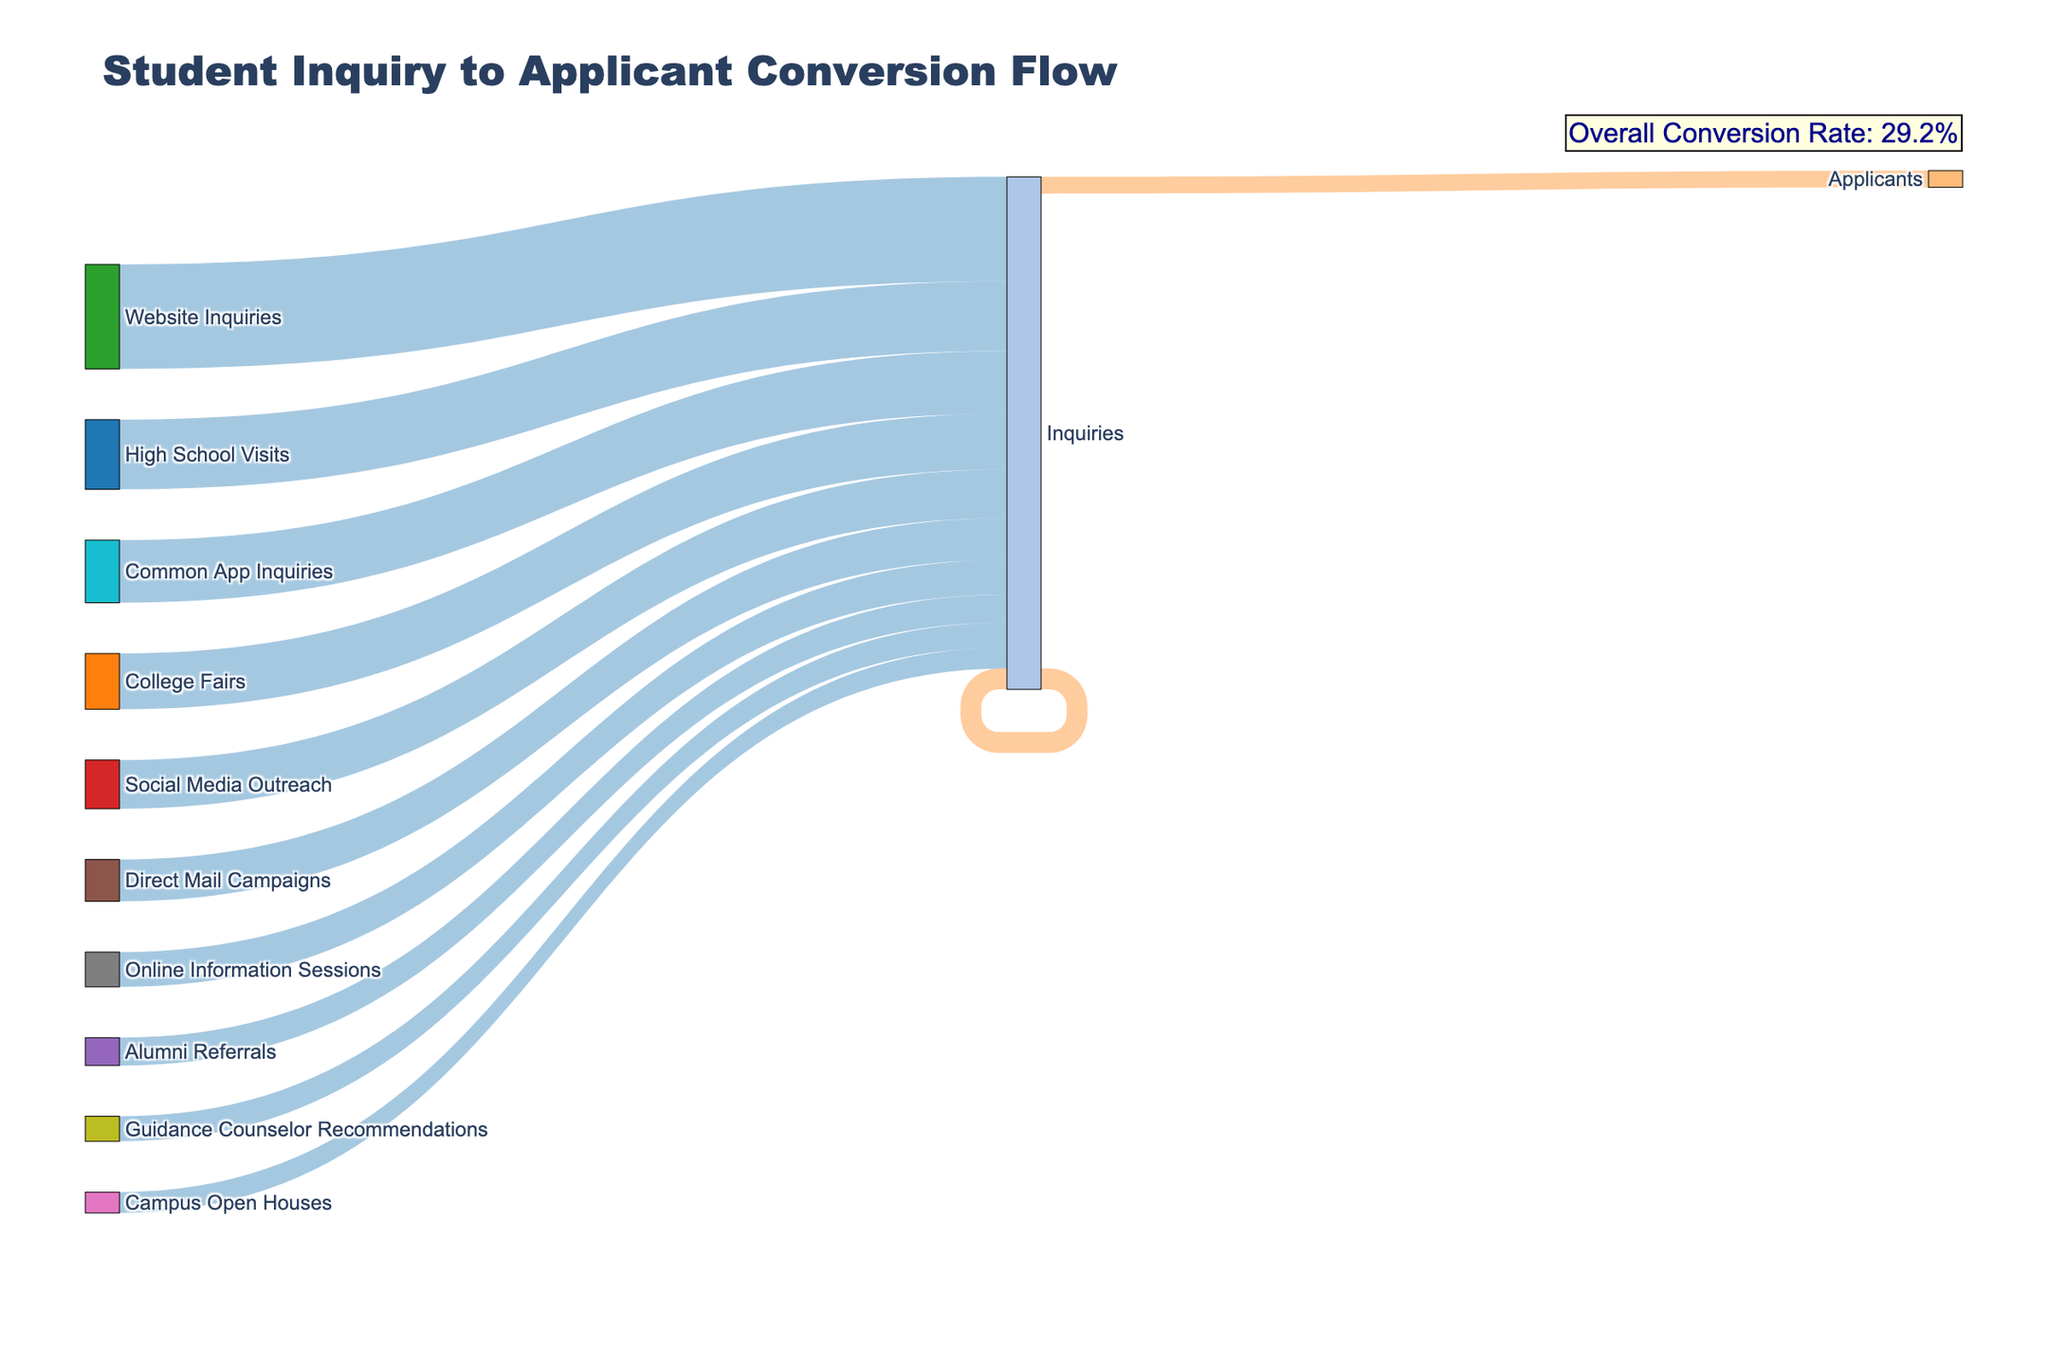What's the title of the figure? The title is usually displayed prominently at the top of the figure. From our code, the title is set as "Student Inquiry to Applicant Conversion Flow" on line 36.
Answer: Student Inquiry to Applicant Conversion Flow Which inquiry source has the highest number of applicants? From the figure, you can trace each inquiry source to the number of applicants connected to it. "Website Inquiries" has the longest flow leading to the applicant node, indicating it as the source with the highest applicants.
Answer: Website Inquiries How many total inquiries are represented in the figure? The total inquiries can be calculated by summing the inquiries from all sources. From our data: 5000 + 4000 + 7500 + 3500 + 2000 + 3000 + 1500 + 2500 + 1800 + 4500 = 35300.
Answer: 35300 What is the overall conversion rate from inquiries to applicants? This was explicitly annotated in the figure as 100 times the ratio of total applicants to total inquiries. We calculated this in the code as follows: Total inquiries = 35300, total applicants = 10600. Conversion rate = (10600 / 35300) * 100% ≈ 30%.
Answer: 30% Which source has the lowest conversion rate to applicants? The conversion rate for each source can be derived by dividing the number of applicants from each source by the number of inquiries from that source and comparing them. From our data: Direct Mail Campaigns (600/3000 = 0.2 or 20%) is the lowest.
Answer: Direct Mail Campaigns Compare the number of applicants from High School Visits and College Fairs. Which source has more applicants? By referring to the figure, we observe the flow lines for each source and see the respective connections to the applicant node. High School Visits have 1500 applicants, while College Fairs have 1200. High School Visits produce more applicants.
Answer: High School Visits How many more applicants come from Social Media Outreach compared to Alumni Referrals? Looking at the number of applicants from each source in the figure: 800 (Social Media Outreach) versus 900 (Alumni Referrals). The difference is calculated as 900 - 800.
Answer: 100 fewer applicants Which inquiry source contributes to more than 1000 applicants and came through offline methods? We identify the sources that yield more than 1000 applicants and can be classified as offline. By inspecting the figure, High School Visits (1500) and College Fairs (1200) are the ones that fit this category.
Answer: High School Visits and College Fairs What is the overall contribution (in number) of Guidance Counselor Recommendations to applicants? By referring to the flow line connected to the Guidance Counselor Recommendations node, we see that it leads to 700 applicants.
Answer: 700 Which sources contribute more applicants than the average number of applicants across all sources? First, calculate the average number of applicants: 10600 applicants / 10 sources = 1060 applicants. Then, identify which sources exceed this value in the figure. Website Inquiries (2000) and High School Visits (1500) exceed the average.
Answer: Website Inquiries, High School Visits 